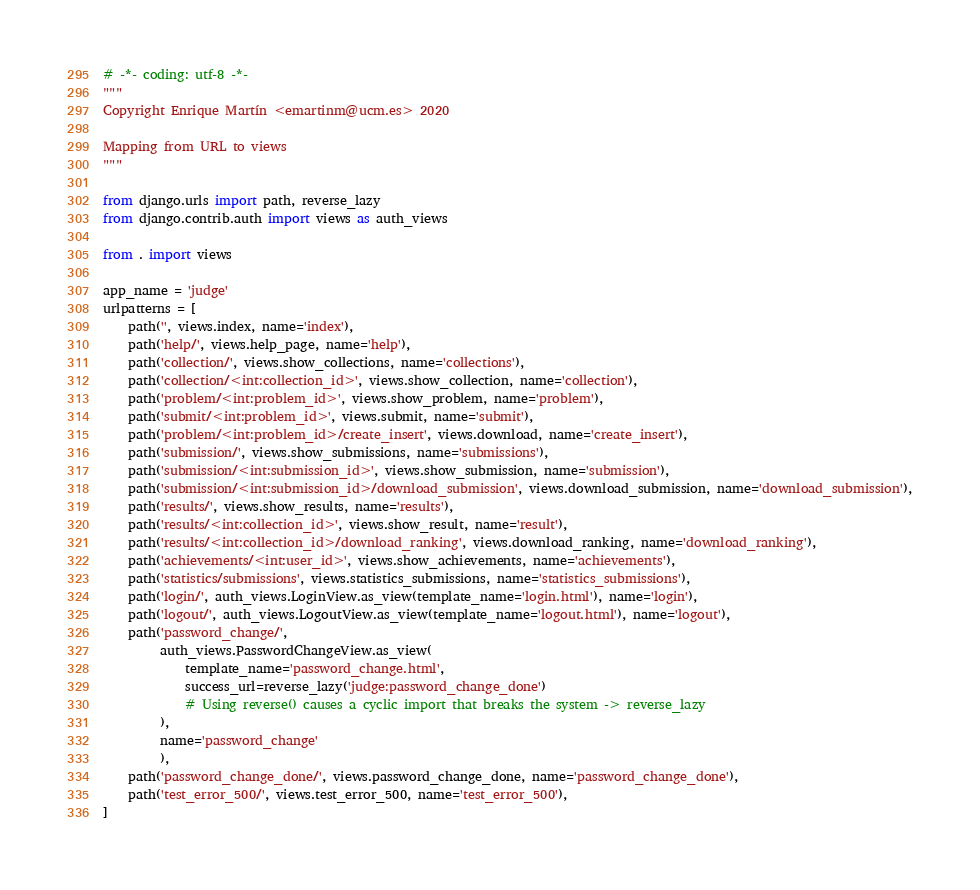Convert code to text. <code><loc_0><loc_0><loc_500><loc_500><_Python_># -*- coding: utf-8 -*-
"""
Copyright Enrique Martín <emartinm@ucm.es> 2020

Mapping from URL to views
"""

from django.urls import path, reverse_lazy
from django.contrib.auth import views as auth_views

from . import views

app_name = 'judge'
urlpatterns = [
    path('', views.index, name='index'),
    path('help/', views.help_page, name='help'),
    path('collection/', views.show_collections, name='collections'),
    path('collection/<int:collection_id>', views.show_collection, name='collection'),
    path('problem/<int:problem_id>', views.show_problem, name='problem'),
    path('submit/<int:problem_id>', views.submit, name='submit'),
    path('problem/<int:problem_id>/create_insert', views.download, name='create_insert'),
    path('submission/', views.show_submissions, name='submissions'),
    path('submission/<int:submission_id>', views.show_submission, name='submission'),
    path('submission/<int:submission_id>/download_submission', views.download_submission, name='download_submission'),
    path('results/', views.show_results, name='results'),
    path('results/<int:collection_id>', views.show_result, name='result'),
    path('results/<int:collection_id>/download_ranking', views.download_ranking, name='download_ranking'),
    path('achievements/<int:user_id>', views.show_achievements, name='achievements'),
    path('statistics/submissions', views.statistics_submissions, name='statistics_submissions'),
    path('login/', auth_views.LoginView.as_view(template_name='login.html'), name='login'),
    path('logout/', auth_views.LogoutView.as_view(template_name='logout.html'), name='logout'),
    path('password_change/',
         auth_views.PasswordChangeView.as_view(
             template_name='password_change.html',
             success_url=reverse_lazy('judge:password_change_done')
             # Using reverse() causes a cyclic import that breaks the system -> reverse_lazy
         ),
         name='password_change'
         ),
    path('password_change_done/', views.password_change_done, name='password_change_done'),
    path('test_error_500/', views.test_error_500, name='test_error_500'),
]
</code> 